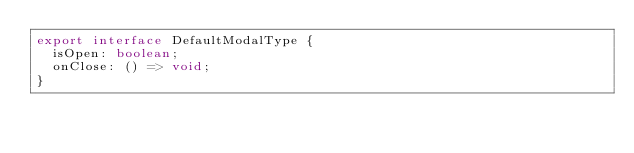Convert code to text. <code><loc_0><loc_0><loc_500><loc_500><_TypeScript_>export interface DefaultModalType {
  isOpen: boolean;
  onClose: () => void;
}
</code> 